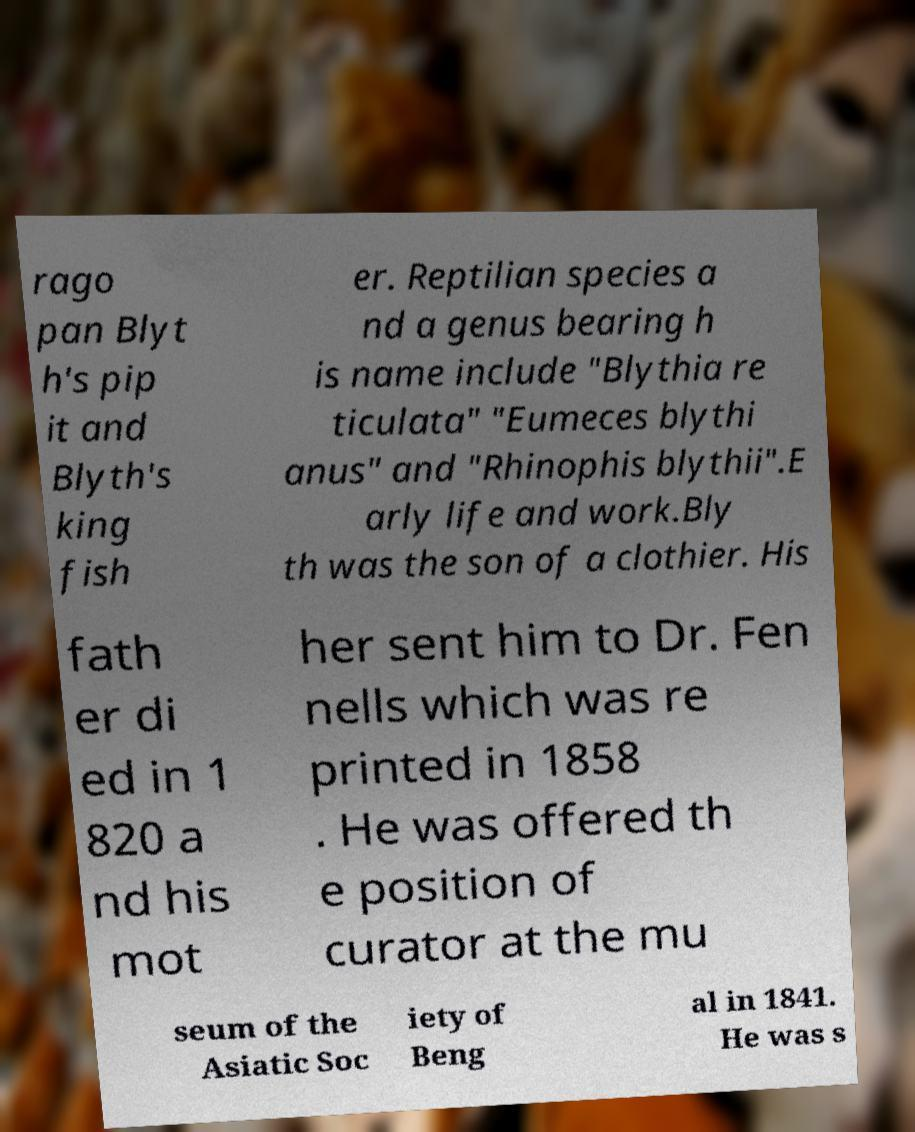Can you accurately transcribe the text from the provided image for me? rago pan Blyt h's pip it and Blyth's king fish er. Reptilian species a nd a genus bearing h is name include "Blythia re ticulata" "Eumeces blythi anus" and "Rhinophis blythii".E arly life and work.Bly th was the son of a clothier. His fath er di ed in 1 820 a nd his mot her sent him to Dr. Fen nells which was re printed in 1858 . He was offered th e position of curator at the mu seum of the Asiatic Soc iety of Beng al in 1841. He was s 